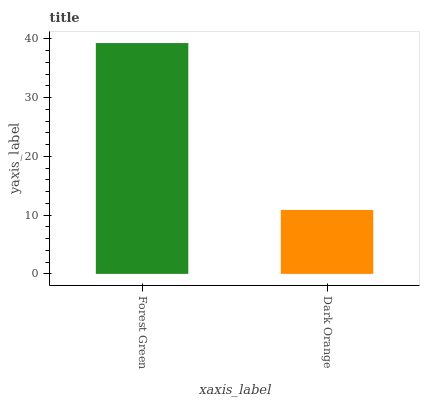Is Dark Orange the minimum?
Answer yes or no. Yes. Is Forest Green the maximum?
Answer yes or no. Yes. Is Dark Orange the maximum?
Answer yes or no. No. Is Forest Green greater than Dark Orange?
Answer yes or no. Yes. Is Dark Orange less than Forest Green?
Answer yes or no. Yes. Is Dark Orange greater than Forest Green?
Answer yes or no. No. Is Forest Green less than Dark Orange?
Answer yes or no. No. Is Forest Green the high median?
Answer yes or no. Yes. Is Dark Orange the low median?
Answer yes or no. Yes. Is Dark Orange the high median?
Answer yes or no. No. Is Forest Green the low median?
Answer yes or no. No. 